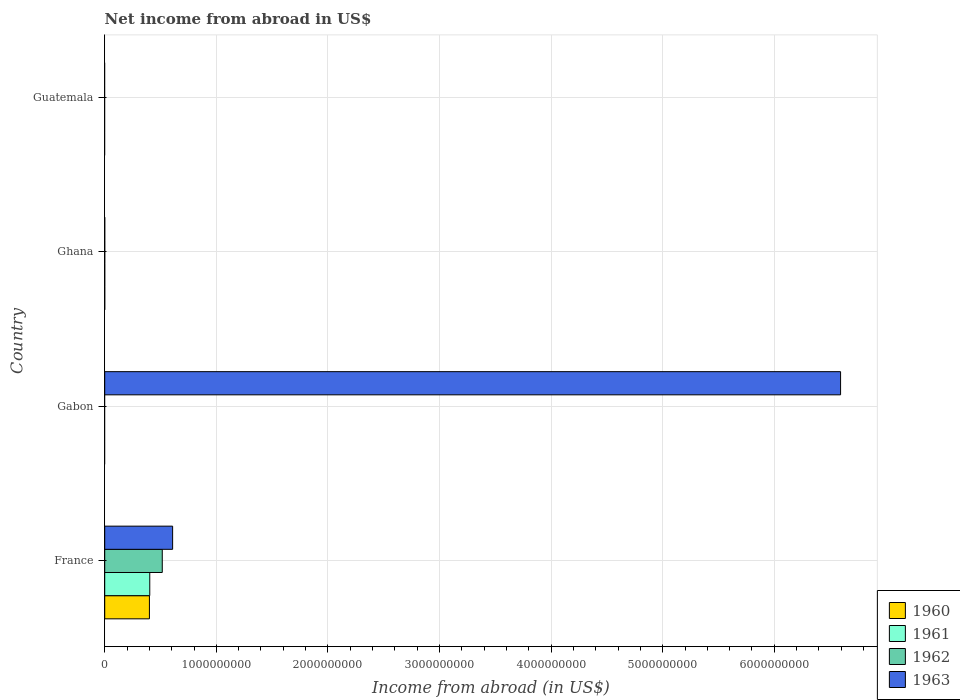How many different coloured bars are there?
Provide a succinct answer. 4. How many bars are there on the 2nd tick from the bottom?
Keep it short and to the point. 1. What is the label of the 3rd group of bars from the top?
Offer a very short reply. Gabon. In how many cases, is the number of bars for a given country not equal to the number of legend labels?
Provide a succinct answer. 3. What is the net income from abroad in 1963 in Gabon?
Your answer should be compact. 6.59e+09. Across all countries, what is the maximum net income from abroad in 1963?
Provide a succinct answer. 6.59e+09. In which country was the net income from abroad in 1961 maximum?
Offer a very short reply. France. What is the total net income from abroad in 1963 in the graph?
Keep it short and to the point. 7.20e+09. What is the difference between the net income from abroad in 1960 in Ghana and the net income from abroad in 1962 in Gabon?
Provide a short and direct response. 0. What is the average net income from abroad in 1962 per country?
Ensure brevity in your answer.  1.29e+08. What is the difference between the net income from abroad in 1962 and net income from abroad in 1960 in France?
Provide a succinct answer. 1.15e+08. What is the difference between the highest and the lowest net income from abroad in 1961?
Your response must be concise. 4.04e+08. How many bars are there?
Offer a terse response. 5. Are all the bars in the graph horizontal?
Give a very brief answer. Yes. Does the graph contain any zero values?
Your answer should be very brief. Yes. How are the legend labels stacked?
Keep it short and to the point. Vertical. What is the title of the graph?
Provide a short and direct response. Net income from abroad in US$. What is the label or title of the X-axis?
Ensure brevity in your answer.  Income from abroad (in US$). What is the Income from abroad (in US$) of 1960 in France?
Offer a very short reply. 4.01e+08. What is the Income from abroad (in US$) of 1961 in France?
Make the answer very short. 4.04e+08. What is the Income from abroad (in US$) of 1962 in France?
Ensure brevity in your answer.  5.16e+08. What is the Income from abroad (in US$) of 1963 in France?
Give a very brief answer. 6.08e+08. What is the Income from abroad (in US$) of 1960 in Gabon?
Ensure brevity in your answer.  0. What is the Income from abroad (in US$) of 1963 in Gabon?
Your answer should be very brief. 6.59e+09. What is the Income from abroad (in US$) in 1960 in Ghana?
Offer a very short reply. 0. What is the Income from abroad (in US$) in 1961 in Ghana?
Provide a short and direct response. 0. What is the Income from abroad (in US$) in 1960 in Guatemala?
Keep it short and to the point. 0. What is the Income from abroad (in US$) of 1962 in Guatemala?
Give a very brief answer. 0. What is the Income from abroad (in US$) in 1963 in Guatemala?
Offer a very short reply. 0. Across all countries, what is the maximum Income from abroad (in US$) in 1960?
Make the answer very short. 4.01e+08. Across all countries, what is the maximum Income from abroad (in US$) in 1961?
Give a very brief answer. 4.04e+08. Across all countries, what is the maximum Income from abroad (in US$) in 1962?
Keep it short and to the point. 5.16e+08. Across all countries, what is the maximum Income from abroad (in US$) in 1963?
Provide a succinct answer. 6.59e+09. Across all countries, what is the minimum Income from abroad (in US$) of 1960?
Ensure brevity in your answer.  0. Across all countries, what is the minimum Income from abroad (in US$) of 1962?
Give a very brief answer. 0. Across all countries, what is the minimum Income from abroad (in US$) of 1963?
Your response must be concise. 0. What is the total Income from abroad (in US$) in 1960 in the graph?
Make the answer very short. 4.01e+08. What is the total Income from abroad (in US$) in 1961 in the graph?
Your answer should be very brief. 4.04e+08. What is the total Income from abroad (in US$) in 1962 in the graph?
Provide a succinct answer. 5.16e+08. What is the total Income from abroad (in US$) of 1963 in the graph?
Keep it short and to the point. 7.20e+09. What is the difference between the Income from abroad (in US$) of 1963 in France and that in Gabon?
Provide a short and direct response. -5.99e+09. What is the difference between the Income from abroad (in US$) in 1960 in France and the Income from abroad (in US$) in 1963 in Gabon?
Keep it short and to the point. -6.19e+09. What is the difference between the Income from abroad (in US$) in 1961 in France and the Income from abroad (in US$) in 1963 in Gabon?
Ensure brevity in your answer.  -6.19e+09. What is the difference between the Income from abroad (in US$) in 1962 in France and the Income from abroad (in US$) in 1963 in Gabon?
Offer a very short reply. -6.08e+09. What is the average Income from abroad (in US$) in 1960 per country?
Offer a terse response. 1.00e+08. What is the average Income from abroad (in US$) of 1961 per country?
Your answer should be compact. 1.01e+08. What is the average Income from abroad (in US$) in 1962 per country?
Your answer should be very brief. 1.29e+08. What is the average Income from abroad (in US$) in 1963 per country?
Provide a succinct answer. 1.80e+09. What is the difference between the Income from abroad (in US$) of 1960 and Income from abroad (in US$) of 1961 in France?
Give a very brief answer. -3.05e+06. What is the difference between the Income from abroad (in US$) of 1960 and Income from abroad (in US$) of 1962 in France?
Offer a very short reply. -1.15e+08. What is the difference between the Income from abroad (in US$) in 1960 and Income from abroad (in US$) in 1963 in France?
Make the answer very short. -2.08e+08. What is the difference between the Income from abroad (in US$) in 1961 and Income from abroad (in US$) in 1962 in France?
Provide a short and direct response. -1.12e+08. What is the difference between the Income from abroad (in US$) in 1961 and Income from abroad (in US$) in 1963 in France?
Your answer should be very brief. -2.05e+08. What is the difference between the Income from abroad (in US$) in 1962 and Income from abroad (in US$) in 1963 in France?
Give a very brief answer. -9.27e+07. What is the ratio of the Income from abroad (in US$) of 1963 in France to that in Gabon?
Your response must be concise. 0.09. What is the difference between the highest and the lowest Income from abroad (in US$) in 1960?
Your answer should be very brief. 4.01e+08. What is the difference between the highest and the lowest Income from abroad (in US$) in 1961?
Your answer should be very brief. 4.04e+08. What is the difference between the highest and the lowest Income from abroad (in US$) in 1962?
Provide a short and direct response. 5.16e+08. What is the difference between the highest and the lowest Income from abroad (in US$) of 1963?
Offer a terse response. 6.59e+09. 